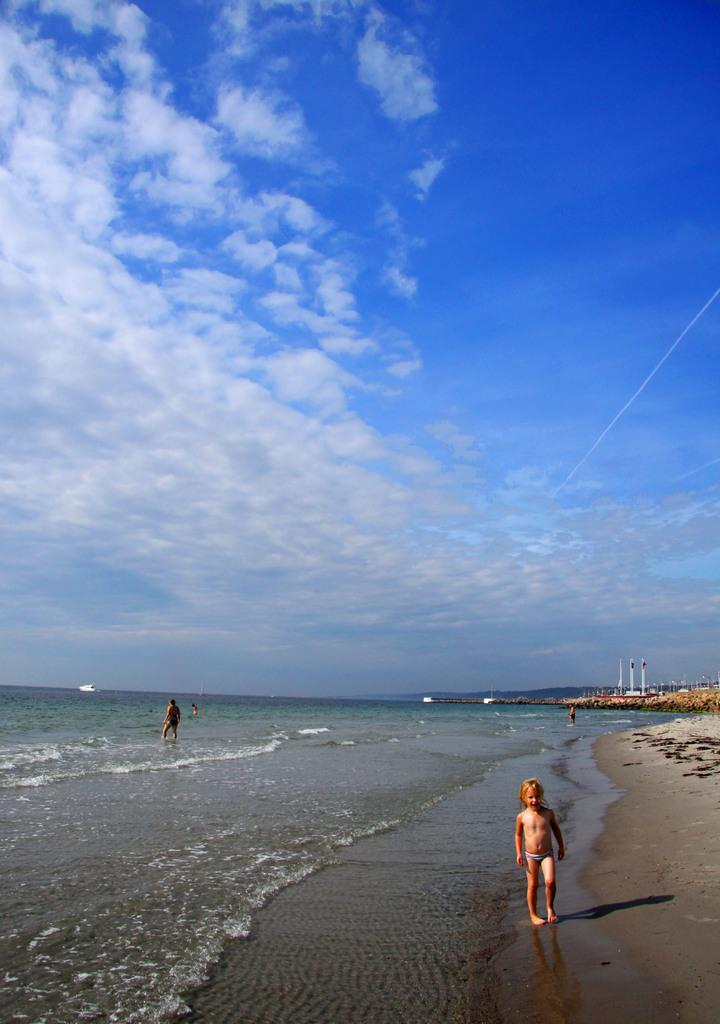What type of location is depicted in the image? There is a beach in the image. Are there any people present at the location? Yes, there are persons on the beach. What can be seen in the sky in the image? The sky is visible in the image, and there are clouds present. Can you describe the bear wearing underwear on the beach in the image? There is no bear or underwear present in the image; it features a beach with people and a visible sky with clouds. 